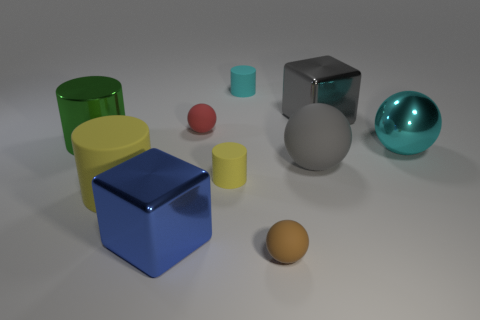Subtract all gray spheres. How many yellow cylinders are left? 2 Subtract all metal balls. How many balls are left? 3 Subtract all gray balls. How many balls are left? 3 Subtract all red balls. Subtract all purple cubes. How many balls are left? 3 Subtract all blocks. How many objects are left? 8 Add 2 small yellow spheres. How many small yellow spheres exist? 2 Subtract 1 green cylinders. How many objects are left? 9 Subtract all tiny things. Subtract all small purple rubber blocks. How many objects are left? 6 Add 4 gray cubes. How many gray cubes are left? 5 